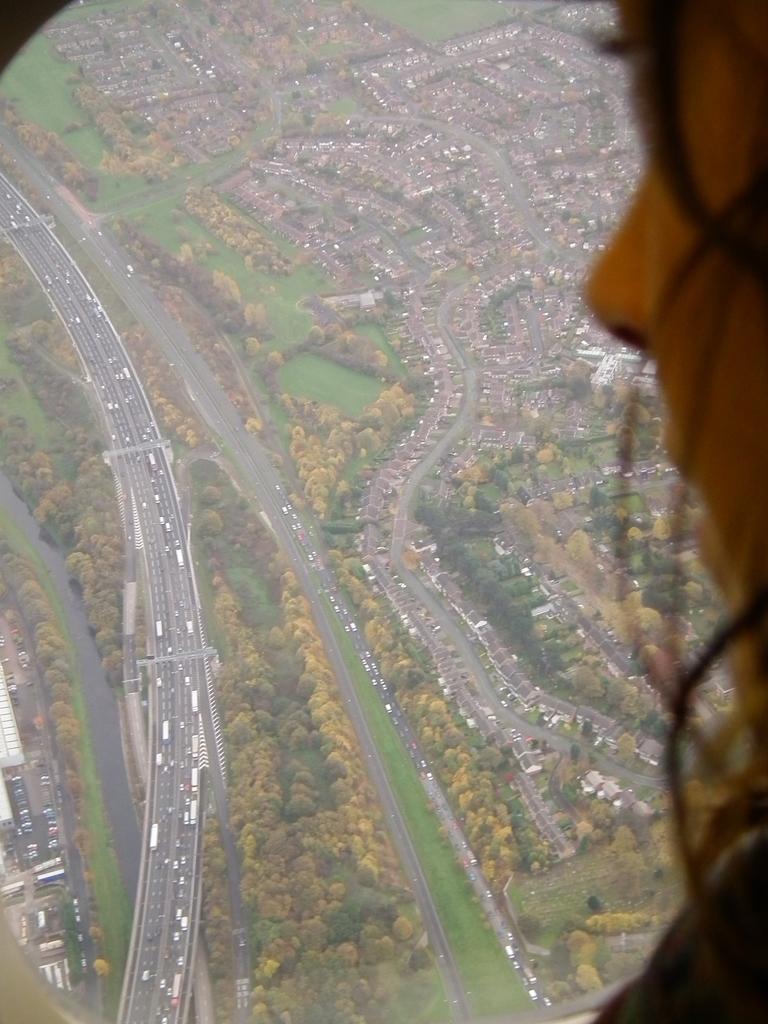Can you describe this image briefly? In this picture I can see a person's face on the right and in the middle of this picture I see the roads, on which there are number of vehicles and I see number of buildings and trees. 